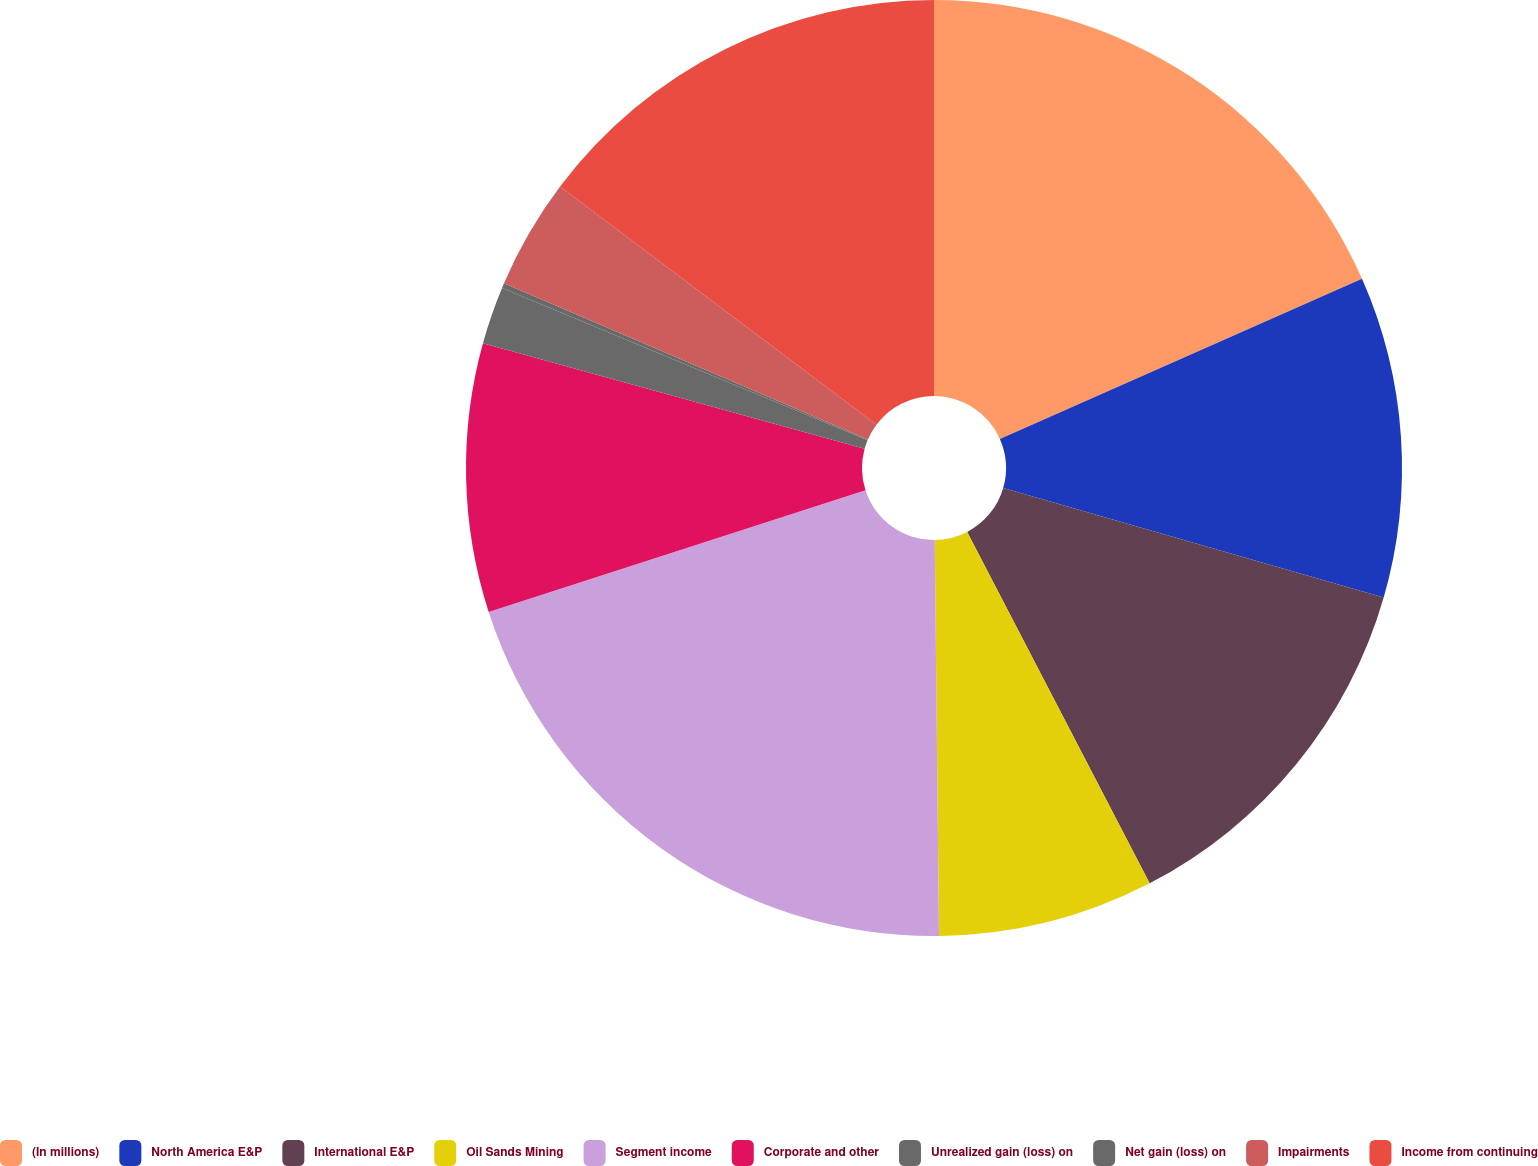<chart> <loc_0><loc_0><loc_500><loc_500><pie_chart><fcel>(In millions)<fcel>North America E&P<fcel>International E&P<fcel>Oil Sands Mining<fcel>Segment income<fcel>Corporate and other<fcel>Unrealized gain (loss) on<fcel>Net gain (loss) on<fcel>Impairments<fcel>Income from continuing<nl><fcel>18.37%<fcel>11.09%<fcel>12.91%<fcel>7.45%<fcel>20.19%<fcel>9.27%<fcel>1.99%<fcel>0.17%<fcel>3.81%<fcel>14.73%<nl></chart> 